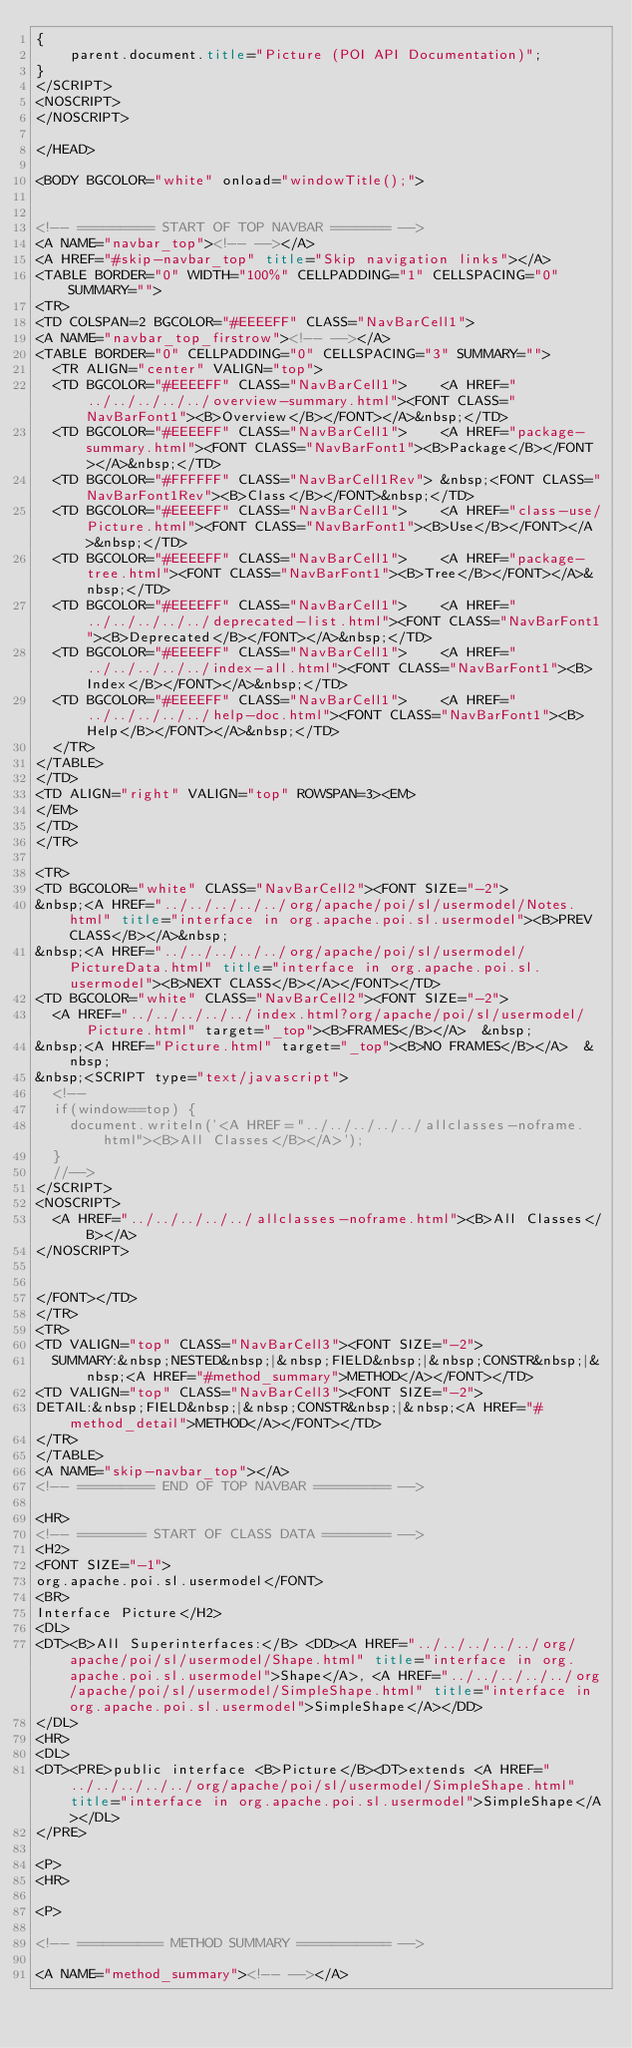<code> <loc_0><loc_0><loc_500><loc_500><_HTML_>{
    parent.document.title="Picture (POI API Documentation)";
}
</SCRIPT>
<NOSCRIPT>
</NOSCRIPT>

</HEAD>

<BODY BGCOLOR="white" onload="windowTitle();">


<!-- ========= START OF TOP NAVBAR ======= -->
<A NAME="navbar_top"><!-- --></A>
<A HREF="#skip-navbar_top" title="Skip navigation links"></A>
<TABLE BORDER="0" WIDTH="100%" CELLPADDING="1" CELLSPACING="0" SUMMARY="">
<TR>
<TD COLSPAN=2 BGCOLOR="#EEEEFF" CLASS="NavBarCell1">
<A NAME="navbar_top_firstrow"><!-- --></A>
<TABLE BORDER="0" CELLPADDING="0" CELLSPACING="3" SUMMARY="">
  <TR ALIGN="center" VALIGN="top">
  <TD BGCOLOR="#EEEEFF" CLASS="NavBarCell1">    <A HREF="../../../../../overview-summary.html"><FONT CLASS="NavBarFont1"><B>Overview</B></FONT></A>&nbsp;</TD>
  <TD BGCOLOR="#EEEEFF" CLASS="NavBarCell1">    <A HREF="package-summary.html"><FONT CLASS="NavBarFont1"><B>Package</B></FONT></A>&nbsp;</TD>
  <TD BGCOLOR="#FFFFFF" CLASS="NavBarCell1Rev"> &nbsp;<FONT CLASS="NavBarFont1Rev"><B>Class</B></FONT>&nbsp;</TD>
  <TD BGCOLOR="#EEEEFF" CLASS="NavBarCell1">    <A HREF="class-use/Picture.html"><FONT CLASS="NavBarFont1"><B>Use</B></FONT></A>&nbsp;</TD>
  <TD BGCOLOR="#EEEEFF" CLASS="NavBarCell1">    <A HREF="package-tree.html"><FONT CLASS="NavBarFont1"><B>Tree</B></FONT></A>&nbsp;</TD>
  <TD BGCOLOR="#EEEEFF" CLASS="NavBarCell1">    <A HREF="../../../../../deprecated-list.html"><FONT CLASS="NavBarFont1"><B>Deprecated</B></FONT></A>&nbsp;</TD>
  <TD BGCOLOR="#EEEEFF" CLASS="NavBarCell1">    <A HREF="../../../../../index-all.html"><FONT CLASS="NavBarFont1"><B>Index</B></FONT></A>&nbsp;</TD>
  <TD BGCOLOR="#EEEEFF" CLASS="NavBarCell1">    <A HREF="../../../../../help-doc.html"><FONT CLASS="NavBarFont1"><B>Help</B></FONT></A>&nbsp;</TD>
  </TR>
</TABLE>
</TD>
<TD ALIGN="right" VALIGN="top" ROWSPAN=3><EM>
</EM>
</TD>
</TR>

<TR>
<TD BGCOLOR="white" CLASS="NavBarCell2"><FONT SIZE="-2">
&nbsp;<A HREF="../../../../../org/apache/poi/sl/usermodel/Notes.html" title="interface in org.apache.poi.sl.usermodel"><B>PREV CLASS</B></A>&nbsp;
&nbsp;<A HREF="../../../../../org/apache/poi/sl/usermodel/PictureData.html" title="interface in org.apache.poi.sl.usermodel"><B>NEXT CLASS</B></A></FONT></TD>
<TD BGCOLOR="white" CLASS="NavBarCell2"><FONT SIZE="-2">
  <A HREF="../../../../../index.html?org/apache/poi/sl/usermodel/Picture.html" target="_top"><B>FRAMES</B></A>  &nbsp;
&nbsp;<A HREF="Picture.html" target="_top"><B>NO FRAMES</B></A>  &nbsp;
&nbsp;<SCRIPT type="text/javascript">
  <!--
  if(window==top) {
    document.writeln('<A HREF="../../../../../allclasses-noframe.html"><B>All Classes</B></A>');
  }
  //-->
</SCRIPT>
<NOSCRIPT>
  <A HREF="../../../../../allclasses-noframe.html"><B>All Classes</B></A>
</NOSCRIPT>


</FONT></TD>
</TR>
<TR>
<TD VALIGN="top" CLASS="NavBarCell3"><FONT SIZE="-2">
  SUMMARY:&nbsp;NESTED&nbsp;|&nbsp;FIELD&nbsp;|&nbsp;CONSTR&nbsp;|&nbsp;<A HREF="#method_summary">METHOD</A></FONT></TD>
<TD VALIGN="top" CLASS="NavBarCell3"><FONT SIZE="-2">
DETAIL:&nbsp;FIELD&nbsp;|&nbsp;CONSTR&nbsp;|&nbsp;<A HREF="#method_detail">METHOD</A></FONT></TD>
</TR>
</TABLE>
<A NAME="skip-navbar_top"></A>
<!-- ========= END OF TOP NAVBAR ========= -->

<HR>
<!-- ======== START OF CLASS DATA ======== -->
<H2>
<FONT SIZE="-1">
org.apache.poi.sl.usermodel</FONT>
<BR>
Interface Picture</H2>
<DL>
<DT><B>All Superinterfaces:</B> <DD><A HREF="../../../../../org/apache/poi/sl/usermodel/Shape.html" title="interface in org.apache.poi.sl.usermodel">Shape</A>, <A HREF="../../../../../org/apache/poi/sl/usermodel/SimpleShape.html" title="interface in org.apache.poi.sl.usermodel">SimpleShape</A></DD>
</DL>
<HR>
<DL>
<DT><PRE>public interface <B>Picture</B><DT>extends <A HREF="../../../../../org/apache/poi/sl/usermodel/SimpleShape.html" title="interface in org.apache.poi.sl.usermodel">SimpleShape</A></DL>
</PRE>

<P>
<HR>

<P>

<!-- ========== METHOD SUMMARY =========== -->

<A NAME="method_summary"><!-- --></A></code> 